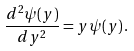Convert formula to latex. <formula><loc_0><loc_0><loc_500><loc_500>\frac { d ^ { 2 } \psi ( y ) } { d y ^ { 2 } } = y \psi ( y ) \, .</formula> 